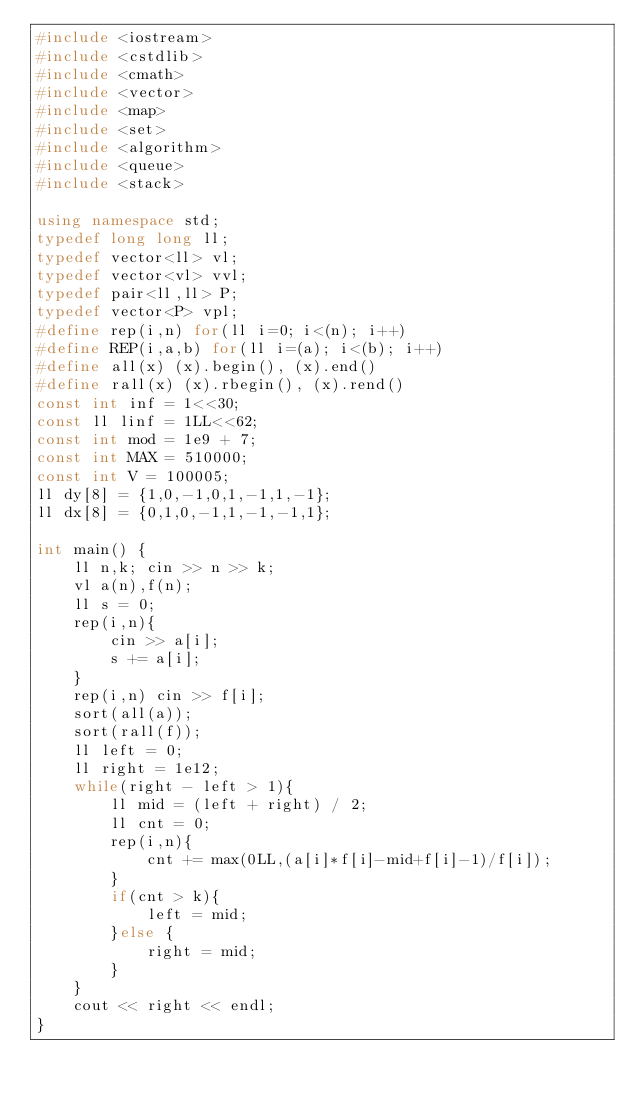<code> <loc_0><loc_0><loc_500><loc_500><_C++_>#include <iostream>
#include <cstdlib>
#include <cmath>
#include <vector>
#include <map>
#include <set>
#include <algorithm>
#include <queue>
#include <stack>

using namespace std;
typedef long long ll;
typedef vector<ll> vl;
typedef vector<vl> vvl;
typedef pair<ll,ll> P;
typedef vector<P> vpl;
#define rep(i,n) for(ll i=0; i<(n); i++)
#define REP(i,a,b) for(ll i=(a); i<(b); i++)
#define all(x) (x).begin(), (x).end()
#define rall(x) (x).rbegin(), (x).rend()
const int inf = 1<<30;
const ll linf = 1LL<<62;
const int mod = 1e9 + 7;
const int MAX = 510000;
const int V = 100005;
ll dy[8] = {1,0,-1,0,1,-1,1,-1};
ll dx[8] = {0,1,0,-1,1,-1,-1,1};

int main() {
    ll n,k; cin >> n >> k;
    vl a(n),f(n);
    ll s = 0;
    rep(i,n){
        cin >> a[i];
        s += a[i];
    }
    rep(i,n) cin >> f[i];
    sort(all(a));
    sort(rall(f));
    ll left = 0;
    ll right = 1e12;
    while(right - left > 1){
        ll mid = (left + right) / 2;
        ll cnt = 0;
        rep(i,n){
            cnt += max(0LL,(a[i]*f[i]-mid+f[i]-1)/f[i]);
        }
        if(cnt > k){
            left = mid;
        }else {
            right = mid;
        }
    }
    cout << right << endl;
}
</code> 